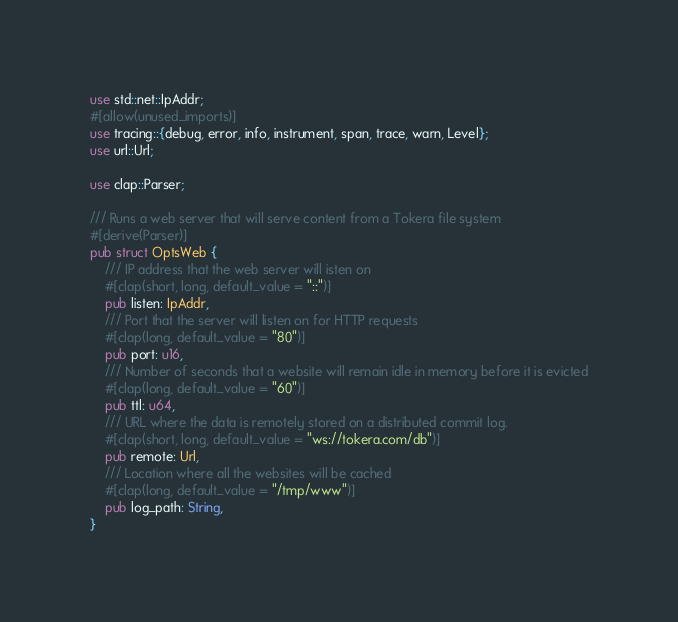<code> <loc_0><loc_0><loc_500><loc_500><_Rust_>use std::net::IpAddr;
#[allow(unused_imports)]
use tracing::{debug, error, info, instrument, span, trace, warn, Level};
use url::Url;

use clap::Parser;

/// Runs a web server that will serve content from a Tokera file system
#[derive(Parser)]
pub struct OptsWeb {
    /// IP address that the web server will isten on
    #[clap(short, long, default_value = "::")]
    pub listen: IpAddr,
    /// Port that the server will listen on for HTTP requests
    #[clap(long, default_value = "80")]
    pub port: u16,
    /// Number of seconds that a website will remain idle in memory before it is evicted
    #[clap(long, default_value = "60")]
    pub ttl: u64,
    /// URL where the data is remotely stored on a distributed commit log.
    #[clap(short, long, default_value = "ws://tokera.com/db")]
    pub remote: Url,
    /// Location where all the websites will be cached
    #[clap(long, default_value = "/tmp/www")]
    pub log_path: String,
}
</code> 